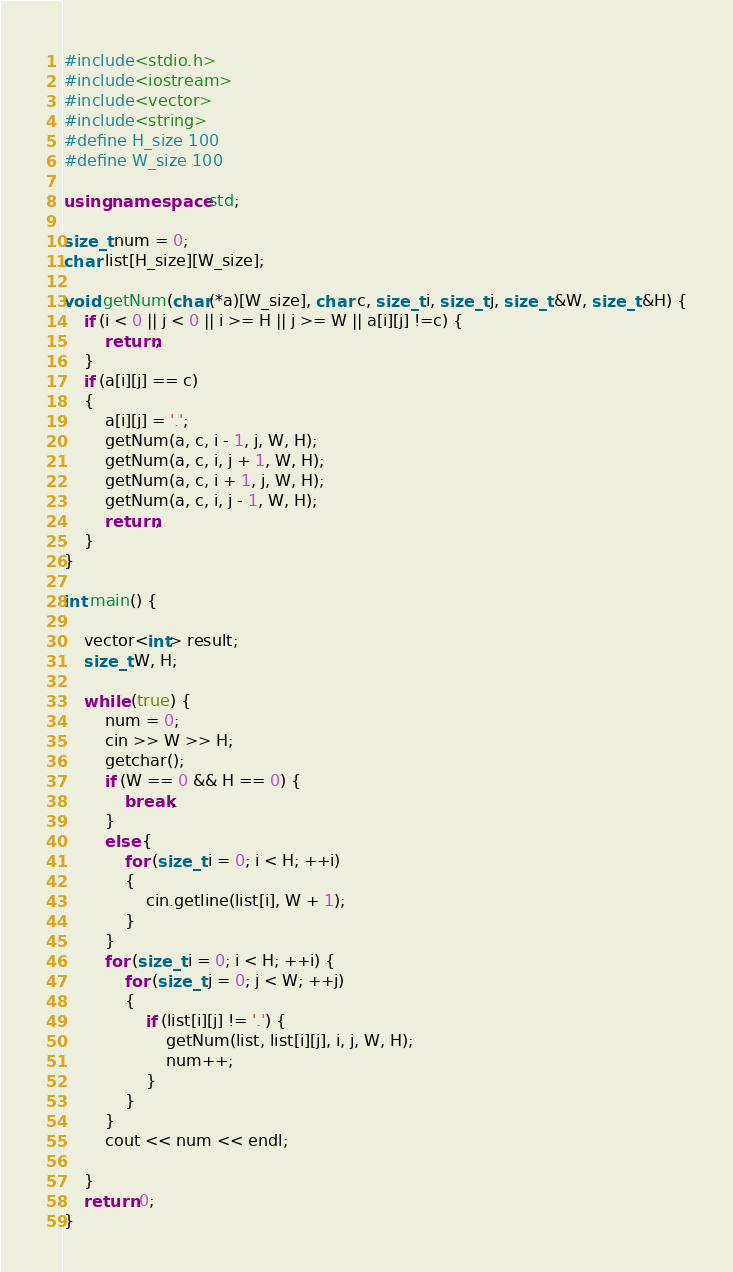Convert code to text. <code><loc_0><loc_0><loc_500><loc_500><_C++_>#include<stdio.h>
#include<iostream>
#include<vector>
#include<string>
#define H_size 100
#define W_size 100

using namespace std;

size_t num = 0;
char list[H_size][W_size];

void getNum(char(*a)[W_size], char c, size_t i, size_t j, size_t &W, size_t &H) {
	if (i < 0 || j < 0 || i >= H || j >= W || a[i][j] !=c) {
		return;
	}
	if (a[i][j] == c)
	{
		a[i][j] = '.';
		getNum(a, c, i - 1, j, W, H);
		getNum(a, c, i, j + 1, W, H);
		getNum(a, c, i + 1, j, W, H);
		getNum(a, c, i, j - 1, W, H);
		return;
	}
}

int main() {

	vector<int> result;
	size_t W, H;
	
	while (true) {
		num = 0;
		cin >> W >> H;
		getchar();
		if (W == 0 && H == 0) {
			break;
		}
		else {
			for (size_t i = 0; i < H; ++i)
			{
				cin.getline(list[i], W + 1);
			}
		}
		for (size_t i = 0; i < H; ++i) {
			for (size_t j = 0; j < W; ++j)
			{
				if (list[i][j] != '.') {
					getNum(list, list[i][j], i, j, W, H);
					num++;
				}
			}
		}
		cout << num << endl;

	}
	return 0;
}</code> 